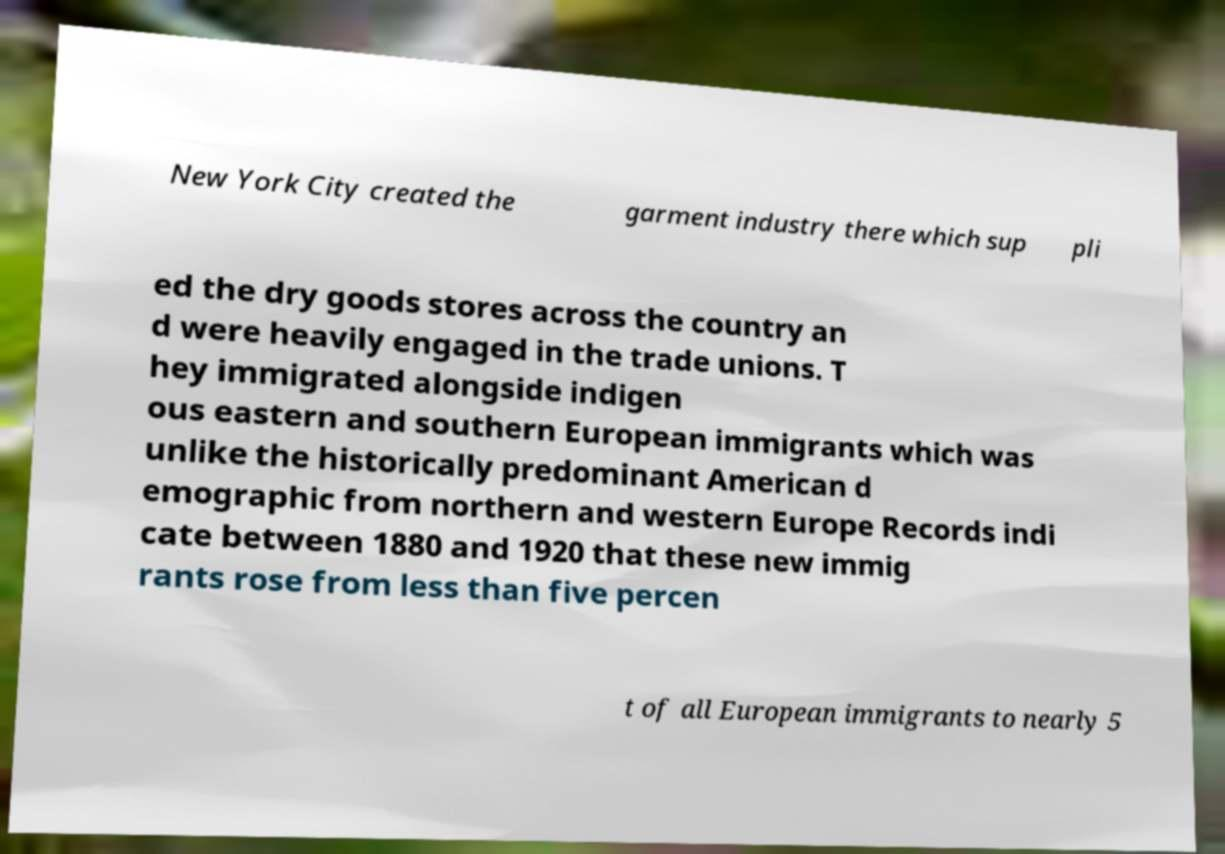Please read and relay the text visible in this image. What does it say? New York City created the garment industry there which sup pli ed the dry goods stores across the country an d were heavily engaged in the trade unions. T hey immigrated alongside indigen ous eastern and southern European immigrants which was unlike the historically predominant American d emographic from northern and western Europe Records indi cate between 1880 and 1920 that these new immig rants rose from less than five percen t of all European immigrants to nearly 5 